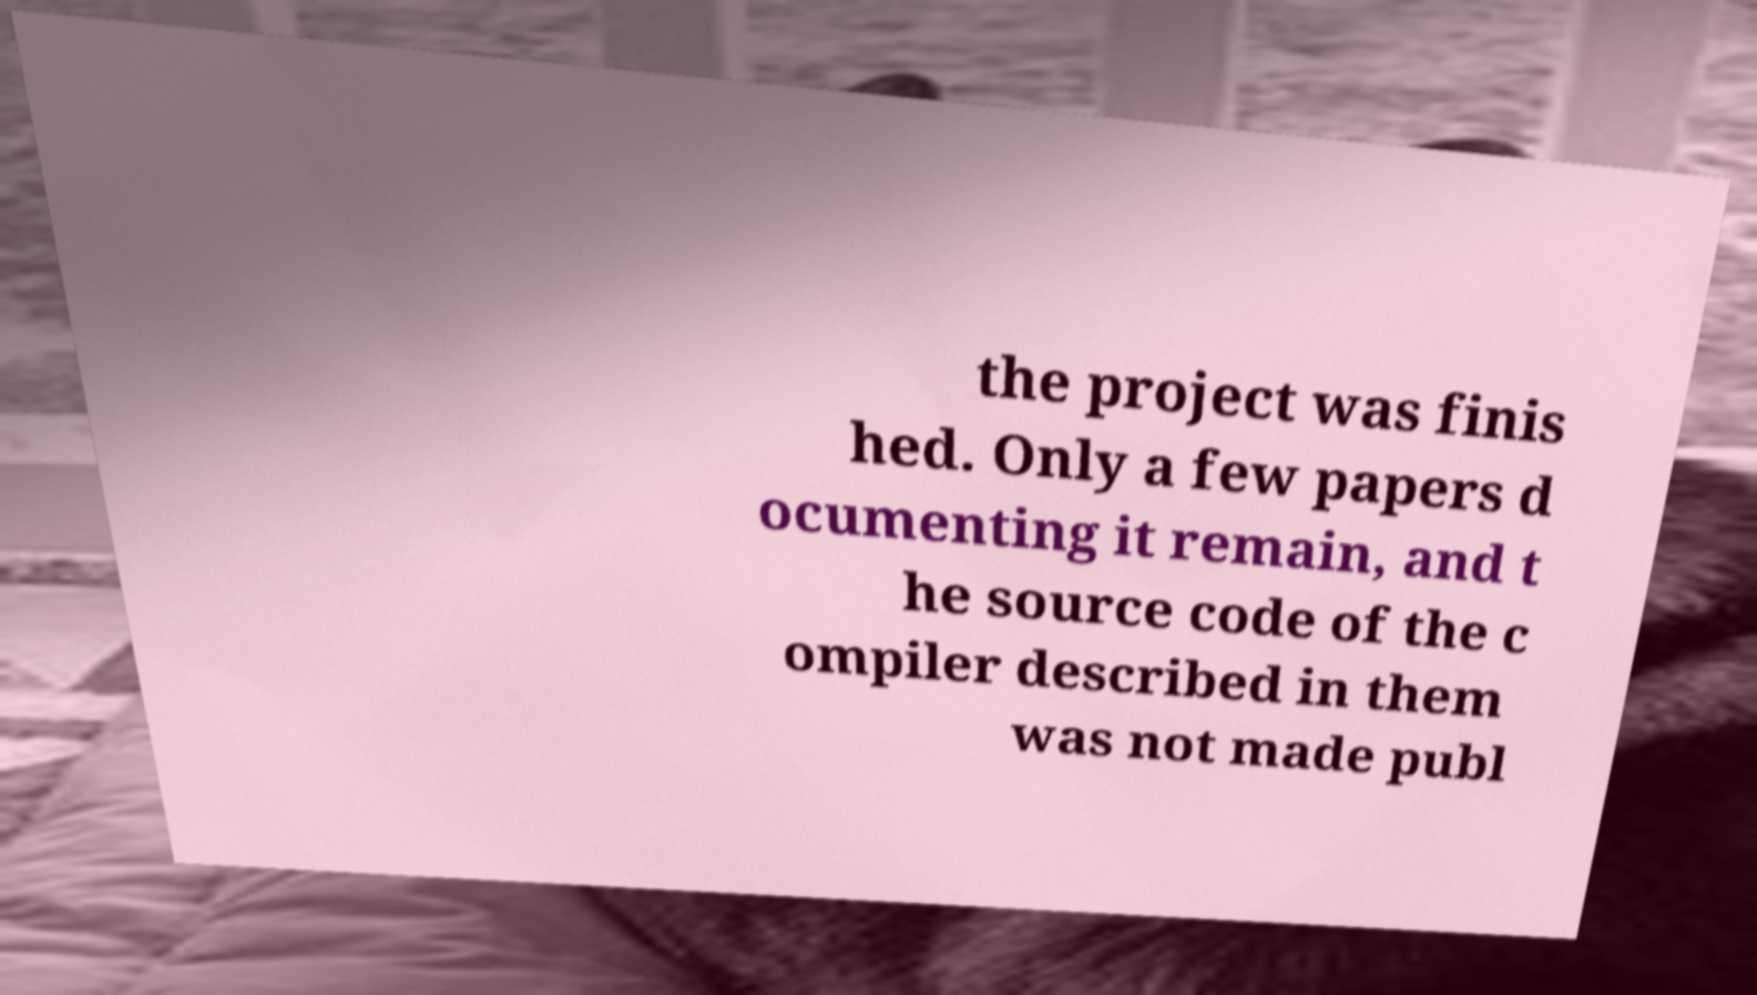There's text embedded in this image that I need extracted. Can you transcribe it verbatim? the project was finis hed. Only a few papers d ocumenting it remain, and t he source code of the c ompiler described in them was not made publ 